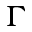Convert formula to latex. <formula><loc_0><loc_0><loc_500><loc_500>\Gamma</formula> 